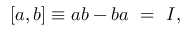Convert formula to latex. <formula><loc_0><loc_0><loc_500><loc_500>[ a , b ] \equiv a b - b a \ = \ I ,</formula> 